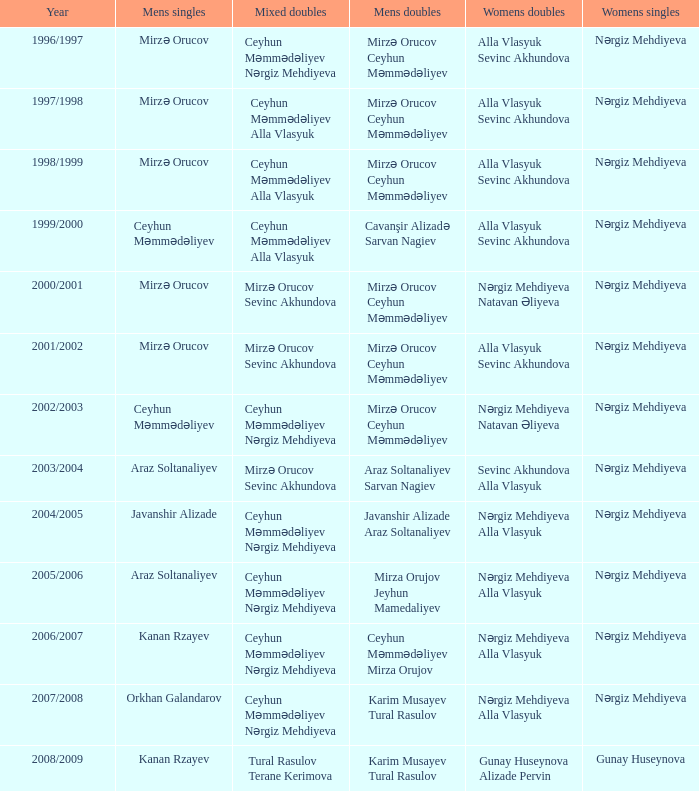Who are all the womens doubles for the year 2008/2009? Gunay Huseynova Alizade Pervin. 